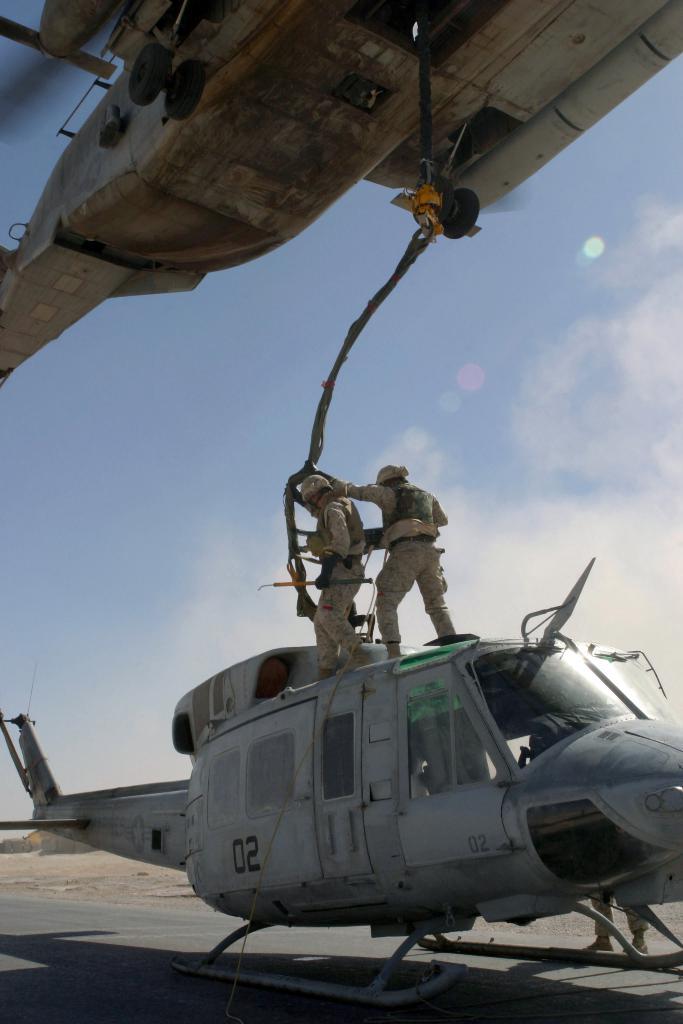What number is on the chopper?
Keep it short and to the point. 02. 